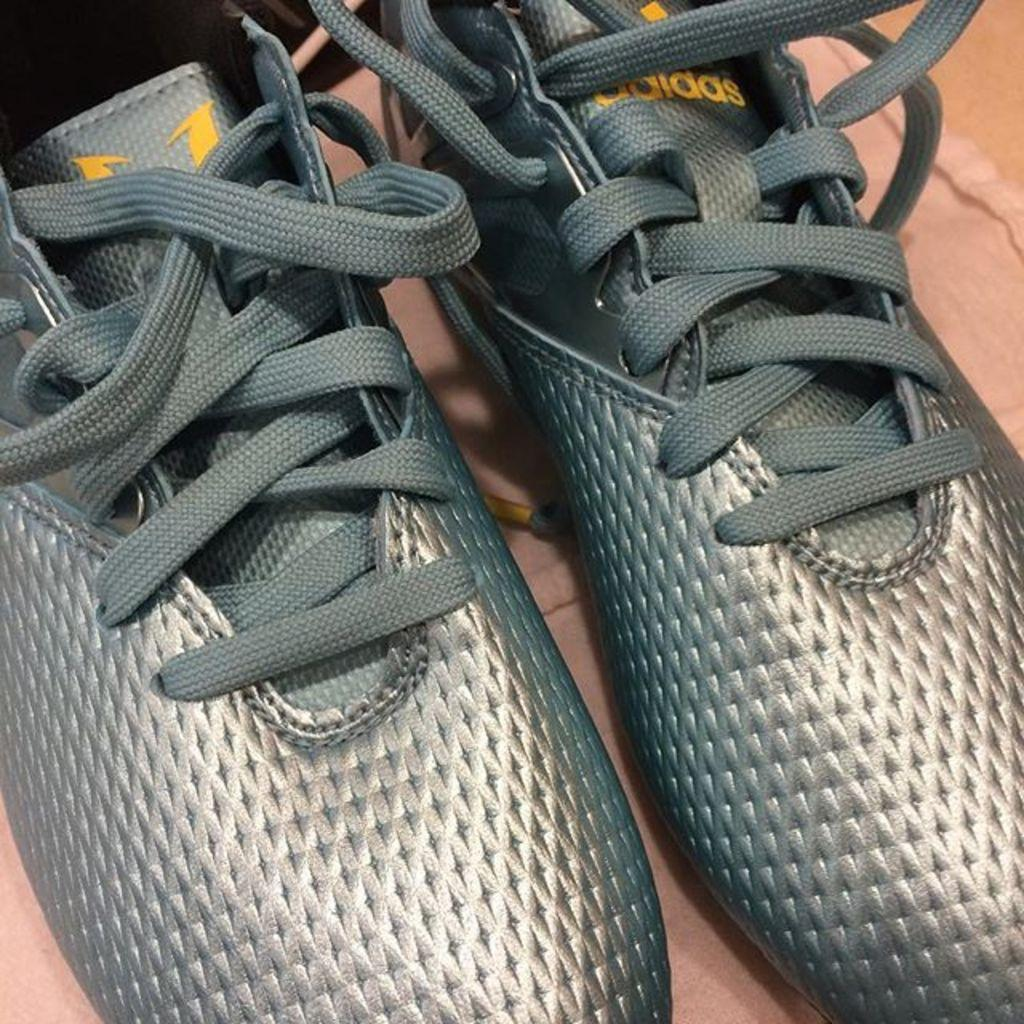What type of footwear is present in the image? There are shoes in the image. What feature do the shoes have? The shoes have laces. Where are the shoes located in the image? The shoes are on the floor. What type of pet can be seen playing with a cord in the image? There is no pet or cord present in the image; it only features shoes on the floor. 